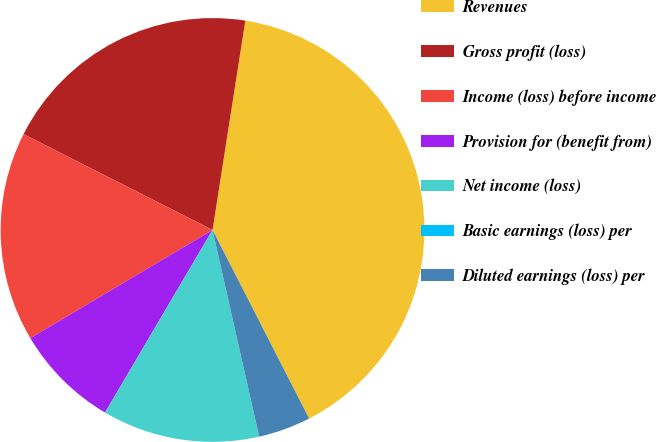Convert chart. <chart><loc_0><loc_0><loc_500><loc_500><pie_chart><fcel>Revenues<fcel>Gross profit (loss)<fcel>Income (loss) before income<fcel>Provision for (benefit from)<fcel>Net income (loss)<fcel>Basic earnings (loss) per<fcel>Diluted earnings (loss) per<nl><fcel>39.99%<fcel>20.0%<fcel>16.0%<fcel>8.0%<fcel>12.0%<fcel>0.0%<fcel>4.0%<nl></chart> 